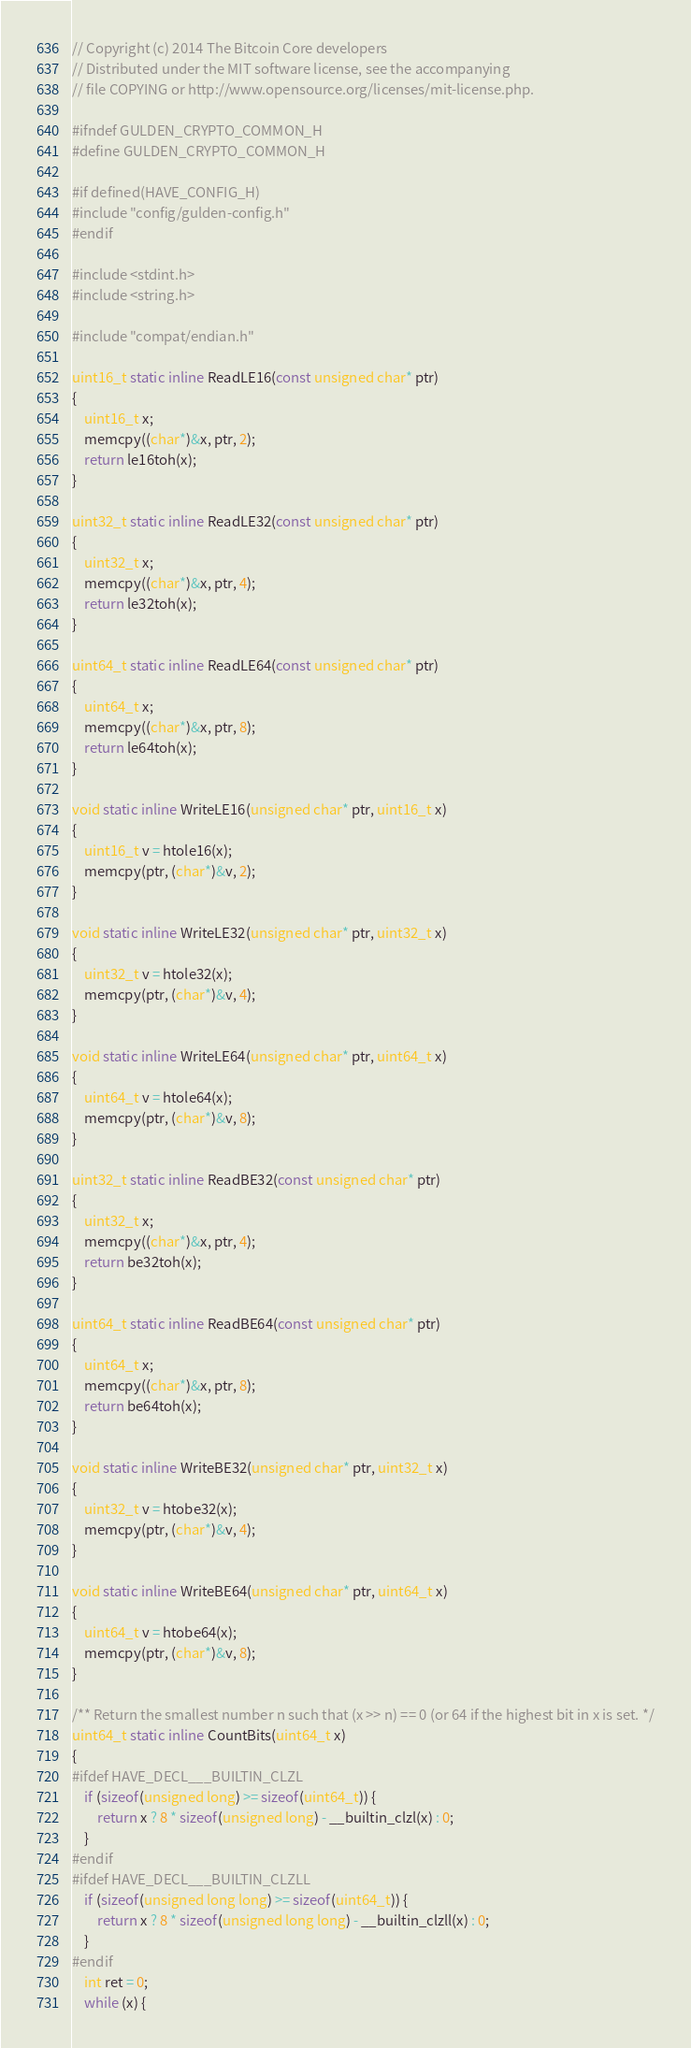Convert code to text. <code><loc_0><loc_0><loc_500><loc_500><_C_>// Copyright (c) 2014 The Bitcoin Core developers
// Distributed under the MIT software license, see the accompanying
// file COPYING or http://www.opensource.org/licenses/mit-license.php.

#ifndef GULDEN_CRYPTO_COMMON_H
#define GULDEN_CRYPTO_COMMON_H

#if defined(HAVE_CONFIG_H)
#include "config/gulden-config.h"
#endif

#include <stdint.h>
#include <string.h>

#include "compat/endian.h"

uint16_t static inline ReadLE16(const unsigned char* ptr)
{
    uint16_t x;
    memcpy((char*)&x, ptr, 2);
    return le16toh(x);
}

uint32_t static inline ReadLE32(const unsigned char* ptr)
{
    uint32_t x;
    memcpy((char*)&x, ptr, 4);
    return le32toh(x);
}

uint64_t static inline ReadLE64(const unsigned char* ptr)
{
    uint64_t x;
    memcpy((char*)&x, ptr, 8);
    return le64toh(x);
}

void static inline WriteLE16(unsigned char* ptr, uint16_t x)
{
    uint16_t v = htole16(x);
    memcpy(ptr, (char*)&v, 2);
}

void static inline WriteLE32(unsigned char* ptr, uint32_t x)
{
    uint32_t v = htole32(x);
    memcpy(ptr, (char*)&v, 4);
}

void static inline WriteLE64(unsigned char* ptr, uint64_t x)
{
    uint64_t v = htole64(x);
    memcpy(ptr, (char*)&v, 8);
}

uint32_t static inline ReadBE32(const unsigned char* ptr)
{
    uint32_t x;
    memcpy((char*)&x, ptr, 4);
    return be32toh(x);
}

uint64_t static inline ReadBE64(const unsigned char* ptr)
{
    uint64_t x;
    memcpy((char*)&x, ptr, 8);
    return be64toh(x);
}

void static inline WriteBE32(unsigned char* ptr, uint32_t x)
{
    uint32_t v = htobe32(x);
    memcpy(ptr, (char*)&v, 4);
}

void static inline WriteBE64(unsigned char* ptr, uint64_t x)
{
    uint64_t v = htobe64(x);
    memcpy(ptr, (char*)&v, 8);
}

/** Return the smallest number n such that (x >> n) == 0 (or 64 if the highest bit in x is set. */
uint64_t static inline CountBits(uint64_t x)
{
#ifdef HAVE_DECL___BUILTIN_CLZL
    if (sizeof(unsigned long) >= sizeof(uint64_t)) {
        return x ? 8 * sizeof(unsigned long) - __builtin_clzl(x) : 0;
    }
#endif
#ifdef HAVE_DECL___BUILTIN_CLZLL
    if (sizeof(unsigned long long) >= sizeof(uint64_t)) {
        return x ? 8 * sizeof(unsigned long long) - __builtin_clzll(x) : 0;
    }
#endif
    int ret = 0;
    while (x) {</code> 